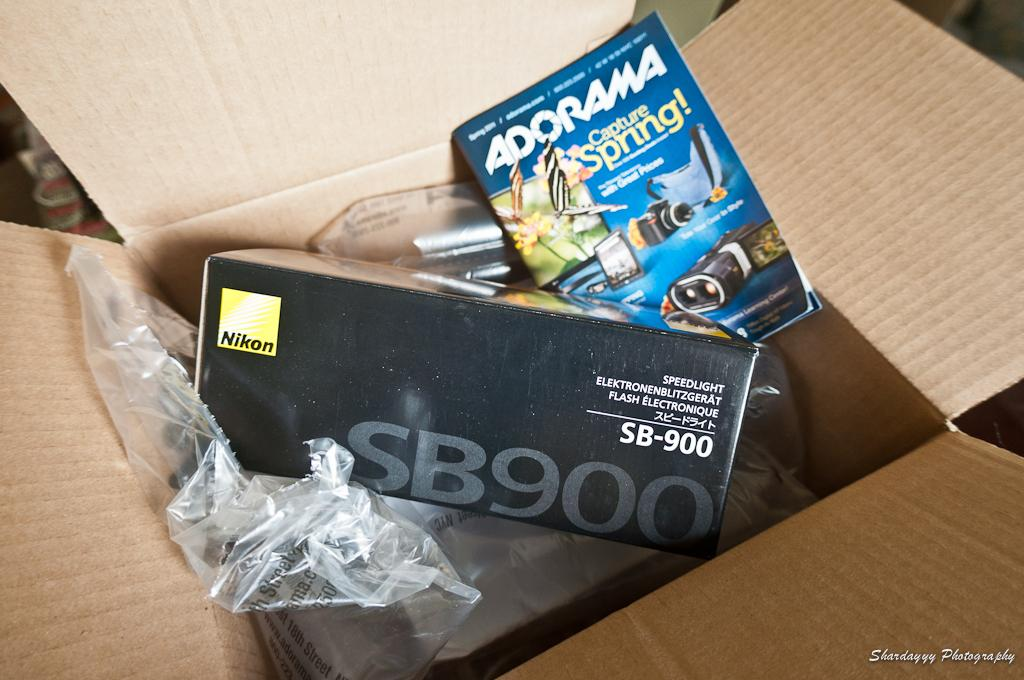What object can be seen in the image that is typically used for reading or learning? There is a book in the image. What other object can be seen in the image that is often used for storage or organization? There is a box in the image. What type of material is covering the items in the image? There are plastic covers in the image. Where are the items located in the image? The items are inside a cardboard box. What type of animal can be seen interacting with the book in the image? There is no animal present in the image, let alone interacting with the book. What tool might be used to hammer a nail in the image? There is no nail or hammer present in the image. 